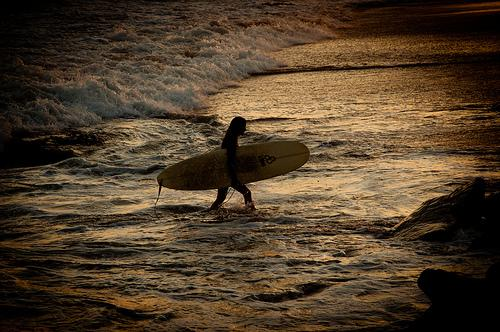Tell me something about the waves in the image. The waves are rough with white foam on top and bubbles, with some waves breaking on the shore. How is the person carrying the surfboard while walking in the water? The person is holding the surfboard horizontally with their right arm, and the front of the board is slightly higher than the back. In the scene, where are the knees of the surfer located in relation to other elements? The surfer's knees are below the surfboard, and the water level is below the knees. Describe the overall appearance and weather conditions of this image. The image depicts an evening setting with coppery hues reflecting on the water surface and soft ripples on the dark sea. Mention the color of the surfboard and any unique detail about it. The surfboard is pale yellow with a lengthwise stringer down the middle and a black logo on the bottom. Identify the primary action that the person in the image is doing while holding the surfboard. The person is carrying the surfboard while walking in the ocean water. Please provide a brief description of the environment surrounding the person with the surfboard. The person is in the ocean with waves crashing on the beach, rocks along the shoreline, and calm water ahead of the wave. What is the surfer's stance and posture in the image? The surfer is leaning slightly forward, with legs splashing water into the air, and the person's feet are hidden in the water. How is the water and its clarity in the image? The water is wet, but not very clear, with swirls of water behind the surfer creating an opaque appearance. What can you observe about the leash and logo on the surfboard? There's a black rip cord/leash attached to the surfboard, and the surf logo is black on the yellow board. The surfboard has a bright red logo on its top. This instruction is misleading because it states that the surfboard has a bright red logo on its top. However, the given information describes a surf logo on the bottom of the board, with no mention of its color being red. Is the leash of the surfboard blue and detached from the surfer? This instruction is misleading because it talks about a blue leash that is detached from the surfer. The given information mentions a leash, but it doesn't specify its color and states that it's tethered to the surfboard, not detached. The rocks along the shoreline are submerged in water. This instruction is misleading because it states that the rocks along the shoreline are submerged in water. However, the given information describes rocks on the beach, not submerged in water. The surfer is standing on the rocks near the beach. This instruction is misleading because it states that the surfer is standing on the rocks near the beach. However, the given information mentions the surfer walking in the water, not standing on rocks. Is the surfer carrying a pink surfboard in the air? The instruction is misleading because it states that the surfboard is pink and the surfer is carrying it in the air, which is incorrect. According to the given information, the surfboard is pale yellow and the surfer is carrying it under their arm, not in the air. Do you see a surfer carrying the surfboard on their head? This instruction is misleading because it asks if the surfer is carrying the surfboard on their head. According to the given information, the surfboard is being carried under the surfer's arm, not on their head. Can you spot the child holding a surfboard? This instruction is misleading because it implies that there is a child holding a surfboard. However, the given information mentions a person holding a surfboard, with no indication that it's a child. Can you see a man riding a wave on a blue surfboard? This instruction is misleading as it asks if a man is riding a wave on a blue surfboard. In the given information, there is no mention of a man riding a wave, and the surfboard is pale yellow, not blue. Find the person swimming in the crystal-clear water. This instruction is misleading because it implies that there is a person swimming in clear water. However, the given information states that the person is walking in the water and that the water isn't clear. Are the waves calm and gentle around the surfer? This instruction is misleading because it asks if the waves are calm and gentle around the surfer. According to the given information, the waves are crashing on the beach, which suggests that they are not calm or gentle. 